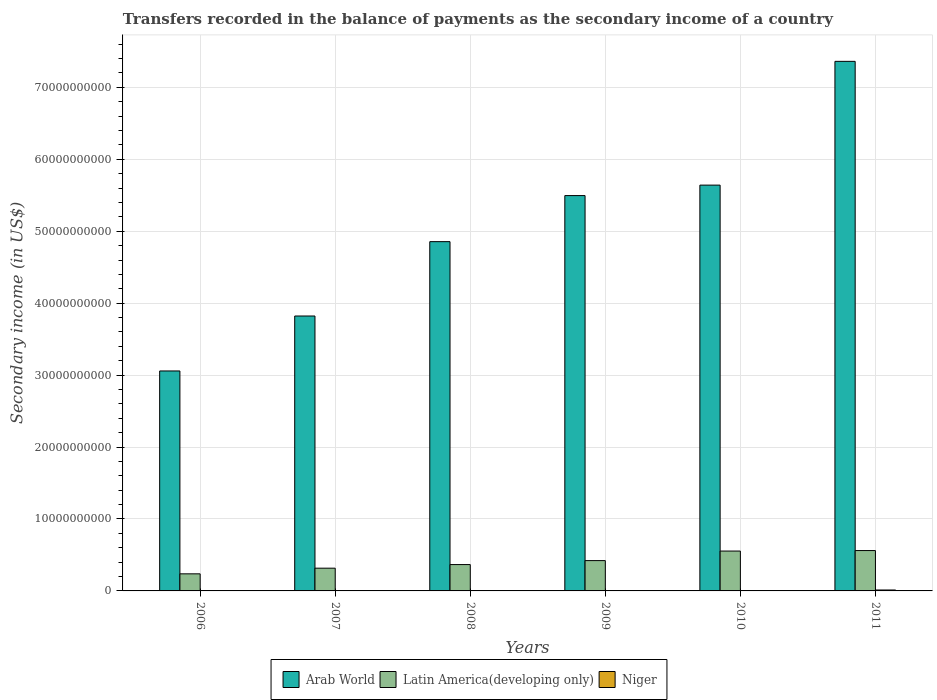How many groups of bars are there?
Your answer should be compact. 6. Are the number of bars per tick equal to the number of legend labels?
Your response must be concise. Yes. What is the secondary income of in Arab World in 2006?
Make the answer very short. 3.06e+1. Across all years, what is the maximum secondary income of in Latin America(developing only)?
Give a very brief answer. 5.61e+09. Across all years, what is the minimum secondary income of in Latin America(developing only)?
Provide a succinct answer. 2.37e+09. In which year was the secondary income of in Niger maximum?
Provide a short and direct response. 2011. What is the total secondary income of in Arab World in the graph?
Offer a very short reply. 3.02e+11. What is the difference between the secondary income of in Arab World in 2009 and that in 2011?
Keep it short and to the point. -1.87e+1. What is the difference between the secondary income of in Arab World in 2010 and the secondary income of in Niger in 2009?
Your answer should be very brief. 5.64e+1. What is the average secondary income of in Arab World per year?
Keep it short and to the point. 5.04e+1. In the year 2008, what is the difference between the secondary income of in Latin America(developing only) and secondary income of in Arab World?
Your answer should be compact. -4.49e+1. What is the ratio of the secondary income of in Niger in 2008 to that in 2010?
Your answer should be compact. 0.26. Is the difference between the secondary income of in Latin America(developing only) in 2006 and 2007 greater than the difference between the secondary income of in Arab World in 2006 and 2007?
Your answer should be very brief. Yes. What is the difference between the highest and the second highest secondary income of in Latin America(developing only)?
Provide a short and direct response. 7.01e+07. What is the difference between the highest and the lowest secondary income of in Latin America(developing only)?
Provide a short and direct response. 3.24e+09. In how many years, is the secondary income of in Latin America(developing only) greater than the average secondary income of in Latin America(developing only) taken over all years?
Provide a short and direct response. 3. What does the 1st bar from the left in 2010 represents?
Make the answer very short. Arab World. What does the 3rd bar from the right in 2009 represents?
Your answer should be very brief. Arab World. How many bars are there?
Ensure brevity in your answer.  18. Are all the bars in the graph horizontal?
Keep it short and to the point. No. What is the difference between two consecutive major ticks on the Y-axis?
Offer a terse response. 1.00e+1. Are the values on the major ticks of Y-axis written in scientific E-notation?
Ensure brevity in your answer.  No. Does the graph contain any zero values?
Your answer should be very brief. No. Does the graph contain grids?
Provide a short and direct response. Yes. How many legend labels are there?
Give a very brief answer. 3. How are the legend labels stacked?
Provide a succinct answer. Horizontal. What is the title of the graph?
Give a very brief answer. Transfers recorded in the balance of payments as the secondary income of a country. Does "Macao" appear as one of the legend labels in the graph?
Provide a succinct answer. No. What is the label or title of the Y-axis?
Give a very brief answer. Secondary income (in US$). What is the Secondary income (in US$) in Arab World in 2006?
Your answer should be compact. 3.06e+1. What is the Secondary income (in US$) in Latin America(developing only) in 2006?
Your response must be concise. 2.37e+09. What is the Secondary income (in US$) of Niger in 2006?
Provide a succinct answer. 2.80e+07. What is the Secondary income (in US$) of Arab World in 2007?
Offer a terse response. 3.82e+1. What is the Secondary income (in US$) in Latin America(developing only) in 2007?
Keep it short and to the point. 3.16e+09. What is the Secondary income (in US$) in Niger in 2007?
Your answer should be very brief. 1.35e+07. What is the Secondary income (in US$) in Arab World in 2008?
Provide a succinct answer. 4.86e+1. What is the Secondary income (in US$) in Latin America(developing only) in 2008?
Give a very brief answer. 3.66e+09. What is the Secondary income (in US$) in Niger in 2008?
Keep it short and to the point. 1.53e+07. What is the Secondary income (in US$) in Arab World in 2009?
Provide a succinct answer. 5.50e+1. What is the Secondary income (in US$) in Latin America(developing only) in 2009?
Provide a succinct answer. 4.22e+09. What is the Secondary income (in US$) of Niger in 2009?
Provide a short and direct response. 1.69e+07. What is the Secondary income (in US$) in Arab World in 2010?
Make the answer very short. 5.64e+1. What is the Secondary income (in US$) in Latin America(developing only) in 2010?
Provide a succinct answer. 5.54e+09. What is the Secondary income (in US$) of Niger in 2010?
Provide a succinct answer. 5.80e+07. What is the Secondary income (in US$) in Arab World in 2011?
Ensure brevity in your answer.  7.36e+1. What is the Secondary income (in US$) of Latin America(developing only) in 2011?
Provide a succinct answer. 5.61e+09. What is the Secondary income (in US$) in Niger in 2011?
Offer a very short reply. 1.29e+08. Across all years, what is the maximum Secondary income (in US$) in Arab World?
Your answer should be compact. 7.36e+1. Across all years, what is the maximum Secondary income (in US$) of Latin America(developing only)?
Make the answer very short. 5.61e+09. Across all years, what is the maximum Secondary income (in US$) of Niger?
Offer a terse response. 1.29e+08. Across all years, what is the minimum Secondary income (in US$) of Arab World?
Offer a terse response. 3.06e+1. Across all years, what is the minimum Secondary income (in US$) of Latin America(developing only)?
Your response must be concise. 2.37e+09. Across all years, what is the minimum Secondary income (in US$) of Niger?
Make the answer very short. 1.35e+07. What is the total Secondary income (in US$) of Arab World in the graph?
Make the answer very short. 3.02e+11. What is the total Secondary income (in US$) in Latin America(developing only) in the graph?
Provide a short and direct response. 2.46e+1. What is the total Secondary income (in US$) in Niger in the graph?
Keep it short and to the point. 2.61e+08. What is the difference between the Secondary income (in US$) of Arab World in 2006 and that in 2007?
Make the answer very short. -7.64e+09. What is the difference between the Secondary income (in US$) of Latin America(developing only) in 2006 and that in 2007?
Keep it short and to the point. -7.88e+08. What is the difference between the Secondary income (in US$) in Niger in 2006 and that in 2007?
Give a very brief answer. 1.46e+07. What is the difference between the Secondary income (in US$) in Arab World in 2006 and that in 2008?
Your answer should be very brief. -1.80e+1. What is the difference between the Secondary income (in US$) of Latin America(developing only) in 2006 and that in 2008?
Offer a terse response. -1.29e+09. What is the difference between the Secondary income (in US$) in Niger in 2006 and that in 2008?
Offer a very short reply. 1.27e+07. What is the difference between the Secondary income (in US$) of Arab World in 2006 and that in 2009?
Give a very brief answer. -2.44e+1. What is the difference between the Secondary income (in US$) in Latin America(developing only) in 2006 and that in 2009?
Offer a very short reply. -1.84e+09. What is the difference between the Secondary income (in US$) of Niger in 2006 and that in 2009?
Provide a short and direct response. 1.12e+07. What is the difference between the Secondary income (in US$) of Arab World in 2006 and that in 2010?
Your answer should be compact. -2.58e+1. What is the difference between the Secondary income (in US$) in Latin America(developing only) in 2006 and that in 2010?
Make the answer very short. -3.17e+09. What is the difference between the Secondary income (in US$) in Niger in 2006 and that in 2010?
Provide a succinct answer. -3.00e+07. What is the difference between the Secondary income (in US$) in Arab World in 2006 and that in 2011?
Your answer should be compact. -4.30e+1. What is the difference between the Secondary income (in US$) of Latin America(developing only) in 2006 and that in 2011?
Keep it short and to the point. -3.24e+09. What is the difference between the Secondary income (in US$) of Niger in 2006 and that in 2011?
Give a very brief answer. -1.01e+08. What is the difference between the Secondary income (in US$) of Arab World in 2007 and that in 2008?
Your answer should be very brief. -1.03e+1. What is the difference between the Secondary income (in US$) in Latin America(developing only) in 2007 and that in 2008?
Keep it short and to the point. -5.02e+08. What is the difference between the Secondary income (in US$) in Niger in 2007 and that in 2008?
Provide a succinct answer. -1.83e+06. What is the difference between the Secondary income (in US$) of Arab World in 2007 and that in 2009?
Provide a short and direct response. -1.67e+1. What is the difference between the Secondary income (in US$) in Latin America(developing only) in 2007 and that in 2009?
Your response must be concise. -1.05e+09. What is the difference between the Secondary income (in US$) of Niger in 2007 and that in 2009?
Offer a very short reply. -3.37e+06. What is the difference between the Secondary income (in US$) of Arab World in 2007 and that in 2010?
Offer a very short reply. -1.82e+1. What is the difference between the Secondary income (in US$) of Latin America(developing only) in 2007 and that in 2010?
Your response must be concise. -2.38e+09. What is the difference between the Secondary income (in US$) of Niger in 2007 and that in 2010?
Provide a succinct answer. -4.45e+07. What is the difference between the Secondary income (in US$) of Arab World in 2007 and that in 2011?
Offer a terse response. -3.54e+1. What is the difference between the Secondary income (in US$) of Latin America(developing only) in 2007 and that in 2011?
Your answer should be very brief. -2.45e+09. What is the difference between the Secondary income (in US$) in Niger in 2007 and that in 2011?
Provide a succinct answer. -1.16e+08. What is the difference between the Secondary income (in US$) in Arab World in 2008 and that in 2009?
Provide a short and direct response. -6.40e+09. What is the difference between the Secondary income (in US$) of Latin America(developing only) in 2008 and that in 2009?
Your answer should be very brief. -5.52e+08. What is the difference between the Secondary income (in US$) in Niger in 2008 and that in 2009?
Provide a short and direct response. -1.55e+06. What is the difference between the Secondary income (in US$) of Arab World in 2008 and that in 2010?
Keep it short and to the point. -7.86e+09. What is the difference between the Secondary income (in US$) in Latin America(developing only) in 2008 and that in 2010?
Ensure brevity in your answer.  -1.88e+09. What is the difference between the Secondary income (in US$) of Niger in 2008 and that in 2010?
Your answer should be compact. -4.27e+07. What is the difference between the Secondary income (in US$) in Arab World in 2008 and that in 2011?
Your response must be concise. -2.51e+1. What is the difference between the Secondary income (in US$) in Latin America(developing only) in 2008 and that in 2011?
Offer a terse response. -1.95e+09. What is the difference between the Secondary income (in US$) in Niger in 2008 and that in 2011?
Give a very brief answer. -1.14e+08. What is the difference between the Secondary income (in US$) of Arab World in 2009 and that in 2010?
Ensure brevity in your answer.  -1.45e+09. What is the difference between the Secondary income (in US$) in Latin America(developing only) in 2009 and that in 2010?
Your response must be concise. -1.33e+09. What is the difference between the Secondary income (in US$) of Niger in 2009 and that in 2010?
Keep it short and to the point. -4.12e+07. What is the difference between the Secondary income (in US$) of Arab World in 2009 and that in 2011?
Make the answer very short. -1.87e+1. What is the difference between the Secondary income (in US$) of Latin America(developing only) in 2009 and that in 2011?
Your answer should be compact. -1.40e+09. What is the difference between the Secondary income (in US$) of Niger in 2009 and that in 2011?
Offer a very short reply. -1.12e+08. What is the difference between the Secondary income (in US$) in Arab World in 2010 and that in 2011?
Offer a terse response. -1.72e+1. What is the difference between the Secondary income (in US$) in Latin America(developing only) in 2010 and that in 2011?
Provide a short and direct response. -7.01e+07. What is the difference between the Secondary income (in US$) in Niger in 2010 and that in 2011?
Offer a terse response. -7.10e+07. What is the difference between the Secondary income (in US$) in Arab World in 2006 and the Secondary income (in US$) in Latin America(developing only) in 2007?
Your answer should be very brief. 2.74e+1. What is the difference between the Secondary income (in US$) of Arab World in 2006 and the Secondary income (in US$) of Niger in 2007?
Your answer should be very brief. 3.06e+1. What is the difference between the Secondary income (in US$) of Latin America(developing only) in 2006 and the Secondary income (in US$) of Niger in 2007?
Provide a short and direct response. 2.36e+09. What is the difference between the Secondary income (in US$) in Arab World in 2006 and the Secondary income (in US$) in Latin America(developing only) in 2008?
Give a very brief answer. 2.69e+1. What is the difference between the Secondary income (in US$) of Arab World in 2006 and the Secondary income (in US$) of Niger in 2008?
Offer a terse response. 3.06e+1. What is the difference between the Secondary income (in US$) of Latin America(developing only) in 2006 and the Secondary income (in US$) of Niger in 2008?
Your answer should be compact. 2.36e+09. What is the difference between the Secondary income (in US$) in Arab World in 2006 and the Secondary income (in US$) in Latin America(developing only) in 2009?
Ensure brevity in your answer.  2.64e+1. What is the difference between the Secondary income (in US$) of Arab World in 2006 and the Secondary income (in US$) of Niger in 2009?
Give a very brief answer. 3.06e+1. What is the difference between the Secondary income (in US$) of Latin America(developing only) in 2006 and the Secondary income (in US$) of Niger in 2009?
Offer a terse response. 2.36e+09. What is the difference between the Secondary income (in US$) of Arab World in 2006 and the Secondary income (in US$) of Latin America(developing only) in 2010?
Offer a terse response. 2.50e+1. What is the difference between the Secondary income (in US$) in Arab World in 2006 and the Secondary income (in US$) in Niger in 2010?
Your answer should be compact. 3.05e+1. What is the difference between the Secondary income (in US$) in Latin America(developing only) in 2006 and the Secondary income (in US$) in Niger in 2010?
Give a very brief answer. 2.32e+09. What is the difference between the Secondary income (in US$) of Arab World in 2006 and the Secondary income (in US$) of Latin America(developing only) in 2011?
Keep it short and to the point. 2.50e+1. What is the difference between the Secondary income (in US$) of Arab World in 2006 and the Secondary income (in US$) of Niger in 2011?
Offer a very short reply. 3.04e+1. What is the difference between the Secondary income (in US$) in Latin America(developing only) in 2006 and the Secondary income (in US$) in Niger in 2011?
Keep it short and to the point. 2.25e+09. What is the difference between the Secondary income (in US$) in Arab World in 2007 and the Secondary income (in US$) in Latin America(developing only) in 2008?
Offer a very short reply. 3.46e+1. What is the difference between the Secondary income (in US$) of Arab World in 2007 and the Secondary income (in US$) of Niger in 2008?
Your answer should be compact. 3.82e+1. What is the difference between the Secondary income (in US$) in Latin America(developing only) in 2007 and the Secondary income (in US$) in Niger in 2008?
Offer a terse response. 3.15e+09. What is the difference between the Secondary income (in US$) in Arab World in 2007 and the Secondary income (in US$) in Latin America(developing only) in 2009?
Provide a succinct answer. 3.40e+1. What is the difference between the Secondary income (in US$) in Arab World in 2007 and the Secondary income (in US$) in Niger in 2009?
Offer a terse response. 3.82e+1. What is the difference between the Secondary income (in US$) of Latin America(developing only) in 2007 and the Secondary income (in US$) of Niger in 2009?
Give a very brief answer. 3.14e+09. What is the difference between the Secondary income (in US$) of Arab World in 2007 and the Secondary income (in US$) of Latin America(developing only) in 2010?
Give a very brief answer. 3.27e+1. What is the difference between the Secondary income (in US$) of Arab World in 2007 and the Secondary income (in US$) of Niger in 2010?
Make the answer very short. 3.82e+1. What is the difference between the Secondary income (in US$) in Latin America(developing only) in 2007 and the Secondary income (in US$) in Niger in 2010?
Keep it short and to the point. 3.10e+09. What is the difference between the Secondary income (in US$) in Arab World in 2007 and the Secondary income (in US$) in Latin America(developing only) in 2011?
Your response must be concise. 3.26e+1. What is the difference between the Secondary income (in US$) in Arab World in 2007 and the Secondary income (in US$) in Niger in 2011?
Give a very brief answer. 3.81e+1. What is the difference between the Secondary income (in US$) of Latin America(developing only) in 2007 and the Secondary income (in US$) of Niger in 2011?
Your response must be concise. 3.03e+09. What is the difference between the Secondary income (in US$) in Arab World in 2008 and the Secondary income (in US$) in Latin America(developing only) in 2009?
Give a very brief answer. 4.43e+1. What is the difference between the Secondary income (in US$) in Arab World in 2008 and the Secondary income (in US$) in Niger in 2009?
Make the answer very short. 4.85e+1. What is the difference between the Secondary income (in US$) of Latin America(developing only) in 2008 and the Secondary income (in US$) of Niger in 2009?
Your answer should be very brief. 3.65e+09. What is the difference between the Secondary income (in US$) in Arab World in 2008 and the Secondary income (in US$) in Latin America(developing only) in 2010?
Ensure brevity in your answer.  4.30e+1. What is the difference between the Secondary income (in US$) of Arab World in 2008 and the Secondary income (in US$) of Niger in 2010?
Provide a succinct answer. 4.85e+1. What is the difference between the Secondary income (in US$) in Latin America(developing only) in 2008 and the Secondary income (in US$) in Niger in 2010?
Offer a very short reply. 3.61e+09. What is the difference between the Secondary income (in US$) in Arab World in 2008 and the Secondary income (in US$) in Latin America(developing only) in 2011?
Ensure brevity in your answer.  4.29e+1. What is the difference between the Secondary income (in US$) of Arab World in 2008 and the Secondary income (in US$) of Niger in 2011?
Offer a very short reply. 4.84e+1. What is the difference between the Secondary income (in US$) in Latin America(developing only) in 2008 and the Secondary income (in US$) in Niger in 2011?
Keep it short and to the point. 3.53e+09. What is the difference between the Secondary income (in US$) in Arab World in 2009 and the Secondary income (in US$) in Latin America(developing only) in 2010?
Ensure brevity in your answer.  4.94e+1. What is the difference between the Secondary income (in US$) of Arab World in 2009 and the Secondary income (in US$) of Niger in 2010?
Keep it short and to the point. 5.49e+1. What is the difference between the Secondary income (in US$) in Latin America(developing only) in 2009 and the Secondary income (in US$) in Niger in 2010?
Make the answer very short. 4.16e+09. What is the difference between the Secondary income (in US$) in Arab World in 2009 and the Secondary income (in US$) in Latin America(developing only) in 2011?
Your answer should be compact. 4.93e+1. What is the difference between the Secondary income (in US$) of Arab World in 2009 and the Secondary income (in US$) of Niger in 2011?
Ensure brevity in your answer.  5.48e+1. What is the difference between the Secondary income (in US$) in Latin America(developing only) in 2009 and the Secondary income (in US$) in Niger in 2011?
Make the answer very short. 4.09e+09. What is the difference between the Secondary income (in US$) of Arab World in 2010 and the Secondary income (in US$) of Latin America(developing only) in 2011?
Offer a terse response. 5.08e+1. What is the difference between the Secondary income (in US$) of Arab World in 2010 and the Secondary income (in US$) of Niger in 2011?
Offer a very short reply. 5.63e+1. What is the difference between the Secondary income (in US$) of Latin America(developing only) in 2010 and the Secondary income (in US$) of Niger in 2011?
Give a very brief answer. 5.41e+09. What is the average Secondary income (in US$) in Arab World per year?
Keep it short and to the point. 5.04e+1. What is the average Secondary income (in US$) in Latin America(developing only) per year?
Your answer should be very brief. 4.09e+09. What is the average Secondary income (in US$) of Niger per year?
Your response must be concise. 4.34e+07. In the year 2006, what is the difference between the Secondary income (in US$) in Arab World and Secondary income (in US$) in Latin America(developing only)?
Keep it short and to the point. 2.82e+1. In the year 2006, what is the difference between the Secondary income (in US$) of Arab World and Secondary income (in US$) of Niger?
Offer a very short reply. 3.05e+1. In the year 2006, what is the difference between the Secondary income (in US$) of Latin America(developing only) and Secondary income (in US$) of Niger?
Provide a succinct answer. 2.35e+09. In the year 2007, what is the difference between the Secondary income (in US$) in Arab World and Secondary income (in US$) in Latin America(developing only)?
Keep it short and to the point. 3.51e+1. In the year 2007, what is the difference between the Secondary income (in US$) in Arab World and Secondary income (in US$) in Niger?
Offer a very short reply. 3.82e+1. In the year 2007, what is the difference between the Secondary income (in US$) in Latin America(developing only) and Secondary income (in US$) in Niger?
Keep it short and to the point. 3.15e+09. In the year 2008, what is the difference between the Secondary income (in US$) in Arab World and Secondary income (in US$) in Latin America(developing only)?
Your answer should be compact. 4.49e+1. In the year 2008, what is the difference between the Secondary income (in US$) in Arab World and Secondary income (in US$) in Niger?
Ensure brevity in your answer.  4.85e+1. In the year 2008, what is the difference between the Secondary income (in US$) of Latin America(developing only) and Secondary income (in US$) of Niger?
Your answer should be compact. 3.65e+09. In the year 2009, what is the difference between the Secondary income (in US$) of Arab World and Secondary income (in US$) of Latin America(developing only)?
Give a very brief answer. 5.07e+1. In the year 2009, what is the difference between the Secondary income (in US$) of Arab World and Secondary income (in US$) of Niger?
Offer a very short reply. 5.49e+1. In the year 2009, what is the difference between the Secondary income (in US$) in Latin America(developing only) and Secondary income (in US$) in Niger?
Make the answer very short. 4.20e+09. In the year 2010, what is the difference between the Secondary income (in US$) in Arab World and Secondary income (in US$) in Latin America(developing only)?
Offer a very short reply. 5.09e+1. In the year 2010, what is the difference between the Secondary income (in US$) of Arab World and Secondary income (in US$) of Niger?
Provide a succinct answer. 5.64e+1. In the year 2010, what is the difference between the Secondary income (in US$) in Latin America(developing only) and Secondary income (in US$) in Niger?
Provide a succinct answer. 5.48e+09. In the year 2011, what is the difference between the Secondary income (in US$) of Arab World and Secondary income (in US$) of Latin America(developing only)?
Keep it short and to the point. 6.80e+1. In the year 2011, what is the difference between the Secondary income (in US$) of Arab World and Secondary income (in US$) of Niger?
Your answer should be very brief. 7.35e+1. In the year 2011, what is the difference between the Secondary income (in US$) in Latin America(developing only) and Secondary income (in US$) in Niger?
Provide a succinct answer. 5.48e+09. What is the ratio of the Secondary income (in US$) of Arab World in 2006 to that in 2007?
Keep it short and to the point. 0.8. What is the ratio of the Secondary income (in US$) in Latin America(developing only) in 2006 to that in 2007?
Your answer should be very brief. 0.75. What is the ratio of the Secondary income (in US$) of Niger in 2006 to that in 2007?
Keep it short and to the point. 2.08. What is the ratio of the Secondary income (in US$) of Arab World in 2006 to that in 2008?
Your response must be concise. 0.63. What is the ratio of the Secondary income (in US$) of Latin America(developing only) in 2006 to that in 2008?
Give a very brief answer. 0.65. What is the ratio of the Secondary income (in US$) of Niger in 2006 to that in 2008?
Offer a very short reply. 1.83. What is the ratio of the Secondary income (in US$) of Arab World in 2006 to that in 2009?
Make the answer very short. 0.56. What is the ratio of the Secondary income (in US$) in Latin America(developing only) in 2006 to that in 2009?
Provide a short and direct response. 0.56. What is the ratio of the Secondary income (in US$) in Niger in 2006 to that in 2009?
Your response must be concise. 1.66. What is the ratio of the Secondary income (in US$) of Arab World in 2006 to that in 2010?
Offer a terse response. 0.54. What is the ratio of the Secondary income (in US$) in Latin America(developing only) in 2006 to that in 2010?
Your answer should be compact. 0.43. What is the ratio of the Secondary income (in US$) of Niger in 2006 to that in 2010?
Make the answer very short. 0.48. What is the ratio of the Secondary income (in US$) of Arab World in 2006 to that in 2011?
Make the answer very short. 0.42. What is the ratio of the Secondary income (in US$) in Latin America(developing only) in 2006 to that in 2011?
Your answer should be compact. 0.42. What is the ratio of the Secondary income (in US$) of Niger in 2006 to that in 2011?
Ensure brevity in your answer.  0.22. What is the ratio of the Secondary income (in US$) in Arab World in 2007 to that in 2008?
Your answer should be compact. 0.79. What is the ratio of the Secondary income (in US$) in Latin America(developing only) in 2007 to that in 2008?
Your response must be concise. 0.86. What is the ratio of the Secondary income (in US$) of Niger in 2007 to that in 2008?
Your answer should be compact. 0.88. What is the ratio of the Secondary income (in US$) in Arab World in 2007 to that in 2009?
Offer a very short reply. 0.7. What is the ratio of the Secondary income (in US$) in Niger in 2007 to that in 2009?
Offer a terse response. 0.8. What is the ratio of the Secondary income (in US$) in Arab World in 2007 to that in 2010?
Your answer should be very brief. 0.68. What is the ratio of the Secondary income (in US$) of Latin America(developing only) in 2007 to that in 2010?
Make the answer very short. 0.57. What is the ratio of the Secondary income (in US$) in Niger in 2007 to that in 2010?
Make the answer very short. 0.23. What is the ratio of the Secondary income (in US$) in Arab World in 2007 to that in 2011?
Offer a very short reply. 0.52. What is the ratio of the Secondary income (in US$) in Latin America(developing only) in 2007 to that in 2011?
Offer a terse response. 0.56. What is the ratio of the Secondary income (in US$) of Niger in 2007 to that in 2011?
Give a very brief answer. 0.1. What is the ratio of the Secondary income (in US$) in Arab World in 2008 to that in 2009?
Your response must be concise. 0.88. What is the ratio of the Secondary income (in US$) of Latin America(developing only) in 2008 to that in 2009?
Offer a terse response. 0.87. What is the ratio of the Secondary income (in US$) of Niger in 2008 to that in 2009?
Give a very brief answer. 0.91. What is the ratio of the Secondary income (in US$) of Arab World in 2008 to that in 2010?
Your answer should be very brief. 0.86. What is the ratio of the Secondary income (in US$) of Latin America(developing only) in 2008 to that in 2010?
Ensure brevity in your answer.  0.66. What is the ratio of the Secondary income (in US$) in Niger in 2008 to that in 2010?
Your response must be concise. 0.26. What is the ratio of the Secondary income (in US$) of Arab World in 2008 to that in 2011?
Provide a short and direct response. 0.66. What is the ratio of the Secondary income (in US$) of Latin America(developing only) in 2008 to that in 2011?
Your response must be concise. 0.65. What is the ratio of the Secondary income (in US$) in Niger in 2008 to that in 2011?
Your answer should be very brief. 0.12. What is the ratio of the Secondary income (in US$) of Arab World in 2009 to that in 2010?
Offer a very short reply. 0.97. What is the ratio of the Secondary income (in US$) of Latin America(developing only) in 2009 to that in 2010?
Your answer should be compact. 0.76. What is the ratio of the Secondary income (in US$) in Niger in 2009 to that in 2010?
Your response must be concise. 0.29. What is the ratio of the Secondary income (in US$) of Arab World in 2009 to that in 2011?
Provide a short and direct response. 0.75. What is the ratio of the Secondary income (in US$) of Latin America(developing only) in 2009 to that in 2011?
Ensure brevity in your answer.  0.75. What is the ratio of the Secondary income (in US$) in Niger in 2009 to that in 2011?
Keep it short and to the point. 0.13. What is the ratio of the Secondary income (in US$) of Arab World in 2010 to that in 2011?
Your response must be concise. 0.77. What is the ratio of the Secondary income (in US$) of Latin America(developing only) in 2010 to that in 2011?
Keep it short and to the point. 0.99. What is the ratio of the Secondary income (in US$) of Niger in 2010 to that in 2011?
Your answer should be very brief. 0.45. What is the difference between the highest and the second highest Secondary income (in US$) of Arab World?
Your answer should be compact. 1.72e+1. What is the difference between the highest and the second highest Secondary income (in US$) of Latin America(developing only)?
Keep it short and to the point. 7.01e+07. What is the difference between the highest and the second highest Secondary income (in US$) of Niger?
Your response must be concise. 7.10e+07. What is the difference between the highest and the lowest Secondary income (in US$) in Arab World?
Keep it short and to the point. 4.30e+1. What is the difference between the highest and the lowest Secondary income (in US$) of Latin America(developing only)?
Make the answer very short. 3.24e+09. What is the difference between the highest and the lowest Secondary income (in US$) of Niger?
Ensure brevity in your answer.  1.16e+08. 